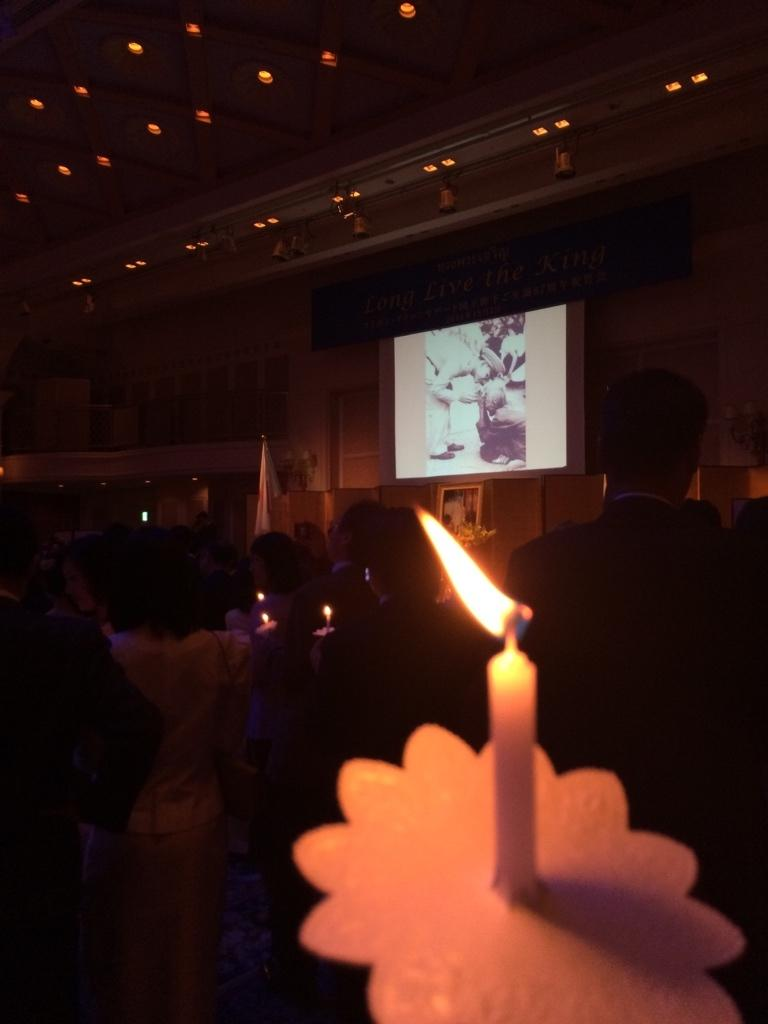What is the overall lighting condition in the image? The image is mostly dark. What is the source of light in the image? There is a candle with a flame in the image. Who or what is present in the image? There are people and a screen in the image. Are there any other sources of light besides the candle? Yes, there are lights visible in the image. What substance is being consumed by the people in the image? There is no indication of any substance being consumed in the image. What trick is being performed by the people in the image? There is no trick being performed by the people in the image. 